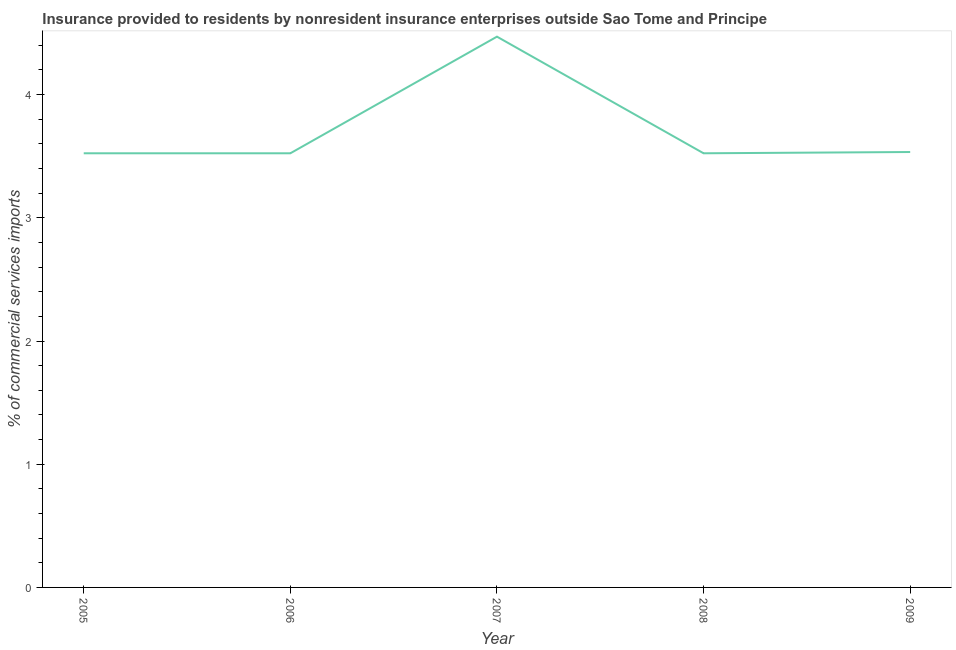What is the insurance provided by non-residents in 2007?
Give a very brief answer. 4.47. Across all years, what is the maximum insurance provided by non-residents?
Keep it short and to the point. 4.47. Across all years, what is the minimum insurance provided by non-residents?
Give a very brief answer. 3.52. In which year was the insurance provided by non-residents maximum?
Offer a very short reply. 2007. In which year was the insurance provided by non-residents minimum?
Keep it short and to the point. 2005. What is the sum of the insurance provided by non-residents?
Offer a very short reply. 18.58. What is the difference between the insurance provided by non-residents in 2006 and 2007?
Keep it short and to the point. -0.95. What is the average insurance provided by non-residents per year?
Make the answer very short. 3.72. What is the median insurance provided by non-residents?
Provide a short and direct response. 3.52. In how many years, is the insurance provided by non-residents greater than 1.2 %?
Your answer should be very brief. 5. What is the ratio of the insurance provided by non-residents in 2006 to that in 2007?
Keep it short and to the point. 0.79. Is the difference between the insurance provided by non-residents in 2005 and 2008 greater than the difference between any two years?
Your response must be concise. No. What is the difference between the highest and the second highest insurance provided by non-residents?
Make the answer very short. 0.94. What is the difference between the highest and the lowest insurance provided by non-residents?
Give a very brief answer. 0.95. In how many years, is the insurance provided by non-residents greater than the average insurance provided by non-residents taken over all years?
Offer a very short reply. 1. Does the insurance provided by non-residents monotonically increase over the years?
Your response must be concise. No. How many lines are there?
Give a very brief answer. 1. How many years are there in the graph?
Offer a terse response. 5. What is the difference between two consecutive major ticks on the Y-axis?
Offer a very short reply. 1. Does the graph contain any zero values?
Your answer should be very brief. No. Does the graph contain grids?
Your answer should be very brief. No. What is the title of the graph?
Provide a succinct answer. Insurance provided to residents by nonresident insurance enterprises outside Sao Tome and Principe. What is the label or title of the Y-axis?
Give a very brief answer. % of commercial services imports. What is the % of commercial services imports of 2005?
Keep it short and to the point. 3.52. What is the % of commercial services imports of 2006?
Offer a very short reply. 3.52. What is the % of commercial services imports in 2007?
Ensure brevity in your answer.  4.47. What is the % of commercial services imports of 2008?
Ensure brevity in your answer.  3.52. What is the % of commercial services imports of 2009?
Give a very brief answer. 3.53. What is the difference between the % of commercial services imports in 2005 and 2006?
Make the answer very short. -0. What is the difference between the % of commercial services imports in 2005 and 2007?
Ensure brevity in your answer.  -0.95. What is the difference between the % of commercial services imports in 2005 and 2008?
Your answer should be compact. -0. What is the difference between the % of commercial services imports in 2005 and 2009?
Offer a very short reply. -0.01. What is the difference between the % of commercial services imports in 2006 and 2007?
Your answer should be very brief. -0.95. What is the difference between the % of commercial services imports in 2006 and 2009?
Your answer should be compact. -0.01. What is the difference between the % of commercial services imports in 2007 and 2008?
Offer a terse response. 0.95. What is the difference between the % of commercial services imports in 2007 and 2009?
Offer a very short reply. 0.94. What is the difference between the % of commercial services imports in 2008 and 2009?
Your response must be concise. -0.01. What is the ratio of the % of commercial services imports in 2005 to that in 2007?
Your answer should be very brief. 0.79. What is the ratio of the % of commercial services imports in 2006 to that in 2007?
Your answer should be very brief. 0.79. What is the ratio of the % of commercial services imports in 2006 to that in 2009?
Provide a succinct answer. 1. What is the ratio of the % of commercial services imports in 2007 to that in 2008?
Offer a terse response. 1.27. What is the ratio of the % of commercial services imports in 2007 to that in 2009?
Your response must be concise. 1.26. 